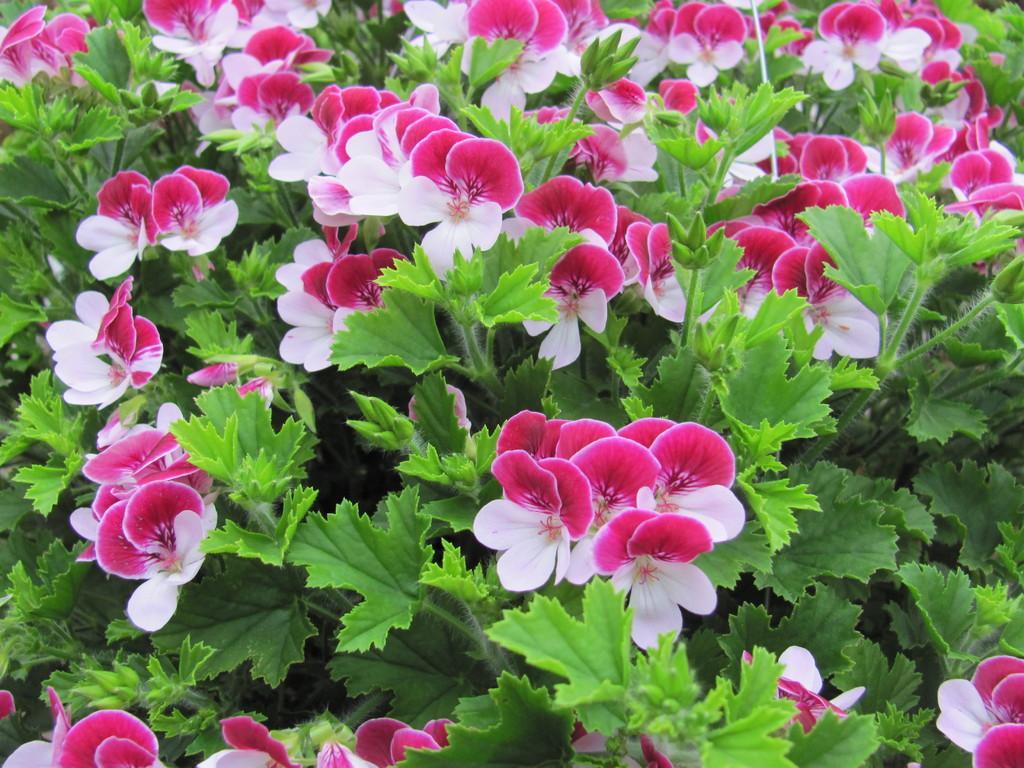Please provide a concise description of this image. In this image we can see a group of plants and flowers. 